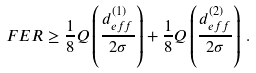Convert formula to latex. <formula><loc_0><loc_0><loc_500><loc_500>F E R \geq \frac { 1 } { 8 } Q \left ( \frac { d ^ { ( 1 ) } _ { e f f } } { 2 \sigma } \right ) + \frac { 1 } { 8 } Q \left ( \frac { d ^ { ( 2 ) } _ { e f f } } { 2 \sigma } \right ) \, .</formula> 